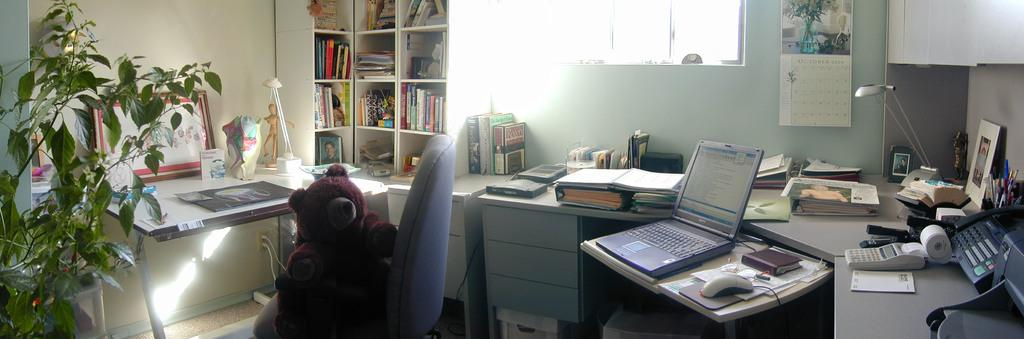What type of living organism can be seen in the image? There is a plant in the image. What object is on the chair in the image? There is a toy on a chair in the image. What furniture is present in the image that might be used for placing items? There are tables with many things in the image. What type of items can be seen on the rack in the image? There is a rack full of books in the image. What architectural feature is visible in the image that allows natural light to enter? There is a window in the image. Can you see a mountain in the background of the image? There is no mountain visible in the image. Is there a throne made of silk in the image? There is no throne or silk present in the image. 